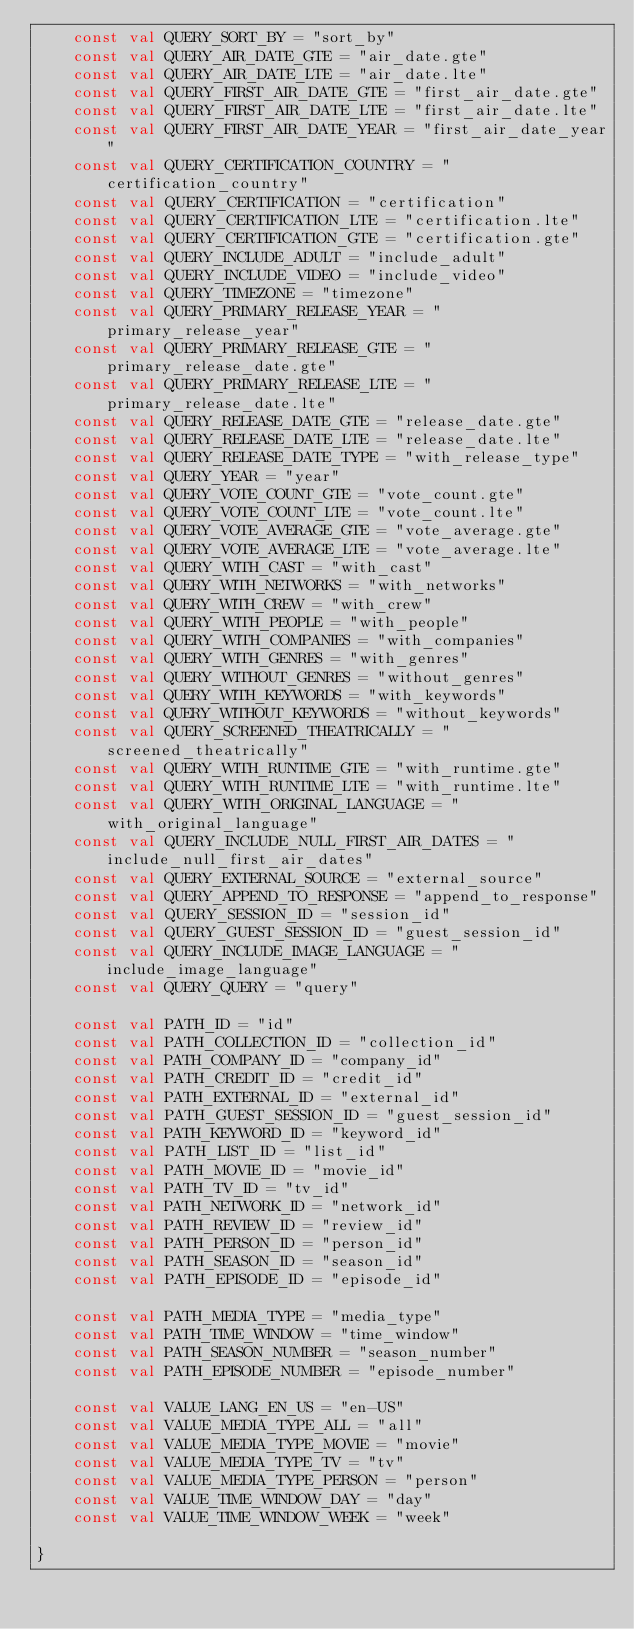Convert code to text. <code><loc_0><loc_0><loc_500><loc_500><_Kotlin_>    const val QUERY_SORT_BY = "sort_by"
    const val QUERY_AIR_DATE_GTE = "air_date.gte"
    const val QUERY_AIR_DATE_LTE = "air_date.lte"
    const val QUERY_FIRST_AIR_DATE_GTE = "first_air_date.gte"
    const val QUERY_FIRST_AIR_DATE_LTE = "first_air_date.lte"
    const val QUERY_FIRST_AIR_DATE_YEAR = "first_air_date_year"
    const val QUERY_CERTIFICATION_COUNTRY = "certification_country"
    const val QUERY_CERTIFICATION = "certification"
    const val QUERY_CERTIFICATION_LTE = "certification.lte"
    const val QUERY_CERTIFICATION_GTE = "certification.gte"
    const val QUERY_INCLUDE_ADULT = "include_adult"
    const val QUERY_INCLUDE_VIDEO = "include_video"
    const val QUERY_TIMEZONE = "timezone"
    const val QUERY_PRIMARY_RELEASE_YEAR = "primary_release_year"
    const val QUERY_PRIMARY_RELEASE_GTE = "primary_release_date.gte"
    const val QUERY_PRIMARY_RELEASE_LTE = "primary_release_date.lte"
    const val QUERY_RELEASE_DATE_GTE = "release_date.gte"
    const val QUERY_RELEASE_DATE_LTE = "release_date.lte"
    const val QUERY_RELEASE_DATE_TYPE = "with_release_type"
    const val QUERY_YEAR = "year"
    const val QUERY_VOTE_COUNT_GTE = "vote_count.gte"
    const val QUERY_VOTE_COUNT_LTE = "vote_count.lte"
    const val QUERY_VOTE_AVERAGE_GTE = "vote_average.gte"
    const val QUERY_VOTE_AVERAGE_LTE = "vote_average.lte"
    const val QUERY_WITH_CAST = "with_cast"
    const val QUERY_WITH_NETWORKS = "with_networks"
    const val QUERY_WITH_CREW = "with_crew"
    const val QUERY_WITH_PEOPLE = "with_people"
    const val QUERY_WITH_COMPANIES = "with_companies"
    const val QUERY_WITH_GENRES = "with_genres"
    const val QUERY_WITHOUT_GENRES = "without_genres"
    const val QUERY_WITH_KEYWORDS = "with_keywords"
    const val QUERY_WITHOUT_KEYWORDS = "without_keywords"
    const val QUERY_SCREENED_THEATRICALLY = "screened_theatrically"
    const val QUERY_WITH_RUNTIME_GTE = "with_runtime.gte"
    const val QUERY_WITH_RUNTIME_LTE = "with_runtime.lte"
    const val QUERY_WITH_ORIGINAL_LANGUAGE = "with_original_language"
    const val QUERY_INCLUDE_NULL_FIRST_AIR_DATES = "include_null_first_air_dates"
    const val QUERY_EXTERNAL_SOURCE = "external_source"
    const val QUERY_APPEND_TO_RESPONSE = "append_to_response"
    const val QUERY_SESSION_ID = "session_id"
    const val QUERY_GUEST_SESSION_ID = "guest_session_id"
    const val QUERY_INCLUDE_IMAGE_LANGUAGE = "include_image_language"
    const val QUERY_QUERY = "query"

    const val PATH_ID = "id"
    const val PATH_COLLECTION_ID = "collection_id"
    const val PATH_COMPANY_ID = "company_id"
    const val PATH_CREDIT_ID = "credit_id"
    const val PATH_EXTERNAL_ID = "external_id"
    const val PATH_GUEST_SESSION_ID = "guest_session_id"
    const val PATH_KEYWORD_ID = "keyword_id"
    const val PATH_LIST_ID = "list_id"
    const val PATH_MOVIE_ID = "movie_id"
    const val PATH_TV_ID = "tv_id"
    const val PATH_NETWORK_ID = "network_id"
    const val PATH_REVIEW_ID = "review_id"
    const val PATH_PERSON_ID = "person_id"
    const val PATH_SEASON_ID = "season_id"
    const val PATH_EPISODE_ID = "episode_id"

    const val PATH_MEDIA_TYPE = "media_type"
    const val PATH_TIME_WINDOW = "time_window"
    const val PATH_SEASON_NUMBER = "season_number"
    const val PATH_EPISODE_NUMBER = "episode_number"

    const val VALUE_LANG_EN_US = "en-US"
    const val VALUE_MEDIA_TYPE_ALL = "all"
    const val VALUE_MEDIA_TYPE_MOVIE = "movie"
    const val VALUE_MEDIA_TYPE_TV = "tv"
    const val VALUE_MEDIA_TYPE_PERSON = "person"
    const val VALUE_TIME_WINDOW_DAY = "day"
    const val VALUE_TIME_WINDOW_WEEK = "week"

}</code> 